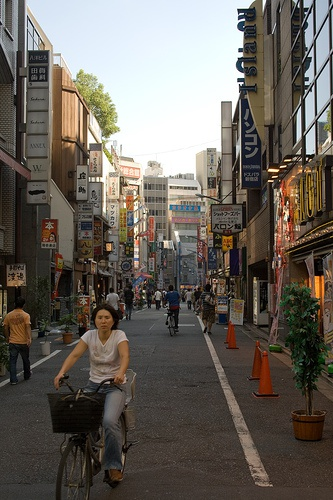Describe the objects in this image and their specific colors. I can see bicycle in gray and black tones, people in gray, black, and maroon tones, potted plant in gray, black, maroon, and darkgreen tones, people in gray, black, maroon, and brown tones, and people in gray and black tones in this image. 